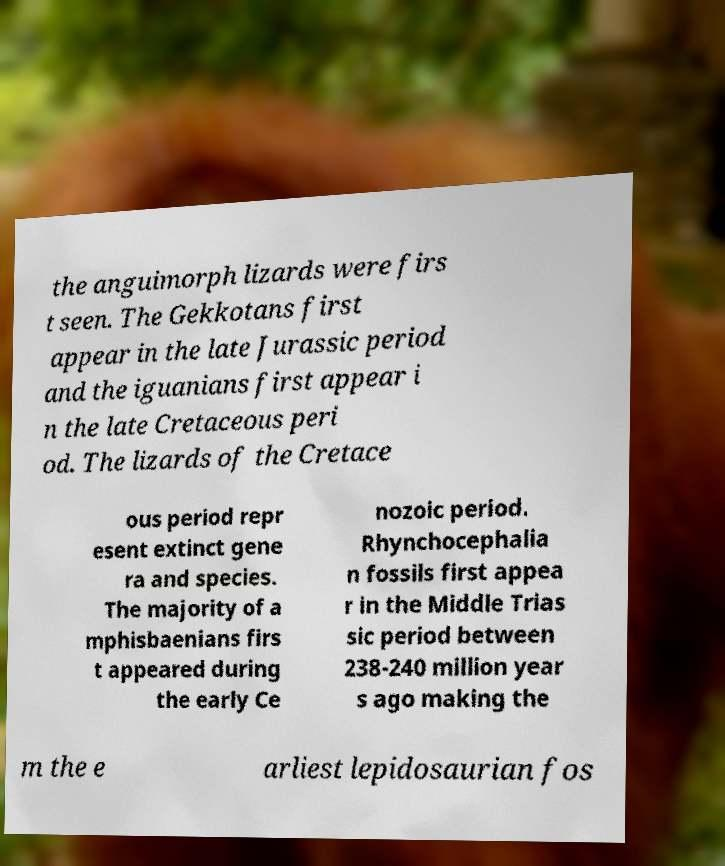Please read and relay the text visible in this image. What does it say? the anguimorph lizards were firs t seen. The Gekkotans first appear in the late Jurassic period and the iguanians first appear i n the late Cretaceous peri od. The lizards of the Cretace ous period repr esent extinct gene ra and species. The majority of a mphisbaenians firs t appeared during the early Ce nozoic period. Rhynchocephalia n fossils first appea r in the Middle Trias sic period between 238-240 million year s ago making the m the e arliest lepidosaurian fos 